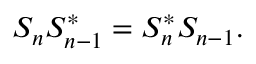Convert formula to latex. <formula><loc_0><loc_0><loc_500><loc_500>S _ { n } S _ { n - 1 } ^ { * } = S _ { n } ^ { * } S _ { n - 1 } .</formula> 